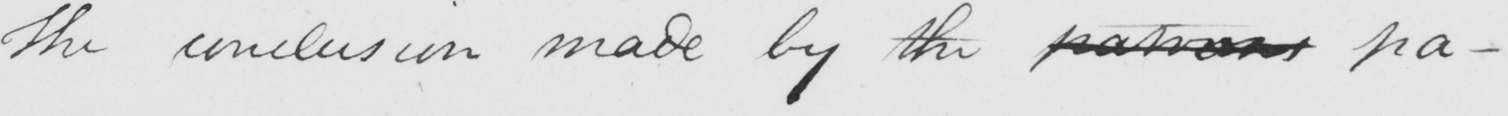What is written in this line of handwriting? The conclusion made by the patrons pa- 